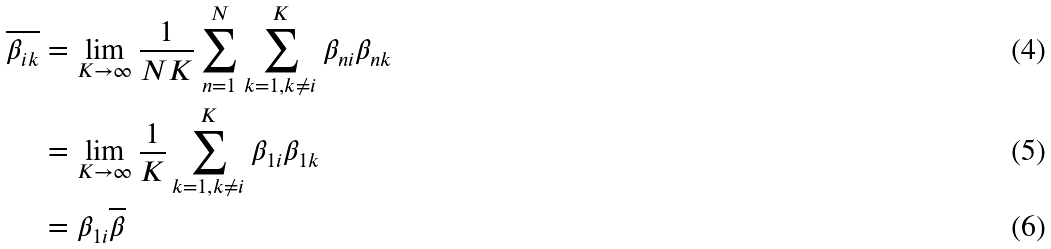Convert formula to latex. <formula><loc_0><loc_0><loc_500><loc_500>\overline { \beta _ { i k } } & = \lim _ { K \to \infty } \frac { 1 } { N K } \sum _ { n = 1 } ^ { N } { \sum _ { k = 1 , k \neq i } ^ { K } { \beta _ { n i } \beta _ { n k } } } \\ & = \lim _ { K \to \infty } \frac { 1 } { K } \sum _ { k = 1 , k \neq i } ^ { K } { \beta _ { 1 i } \beta _ { 1 k } } \\ & = \beta _ { 1 i } \overline { \beta }</formula> 